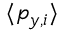<formula> <loc_0><loc_0><loc_500><loc_500>\langle p _ { y , i } \rangle</formula> 